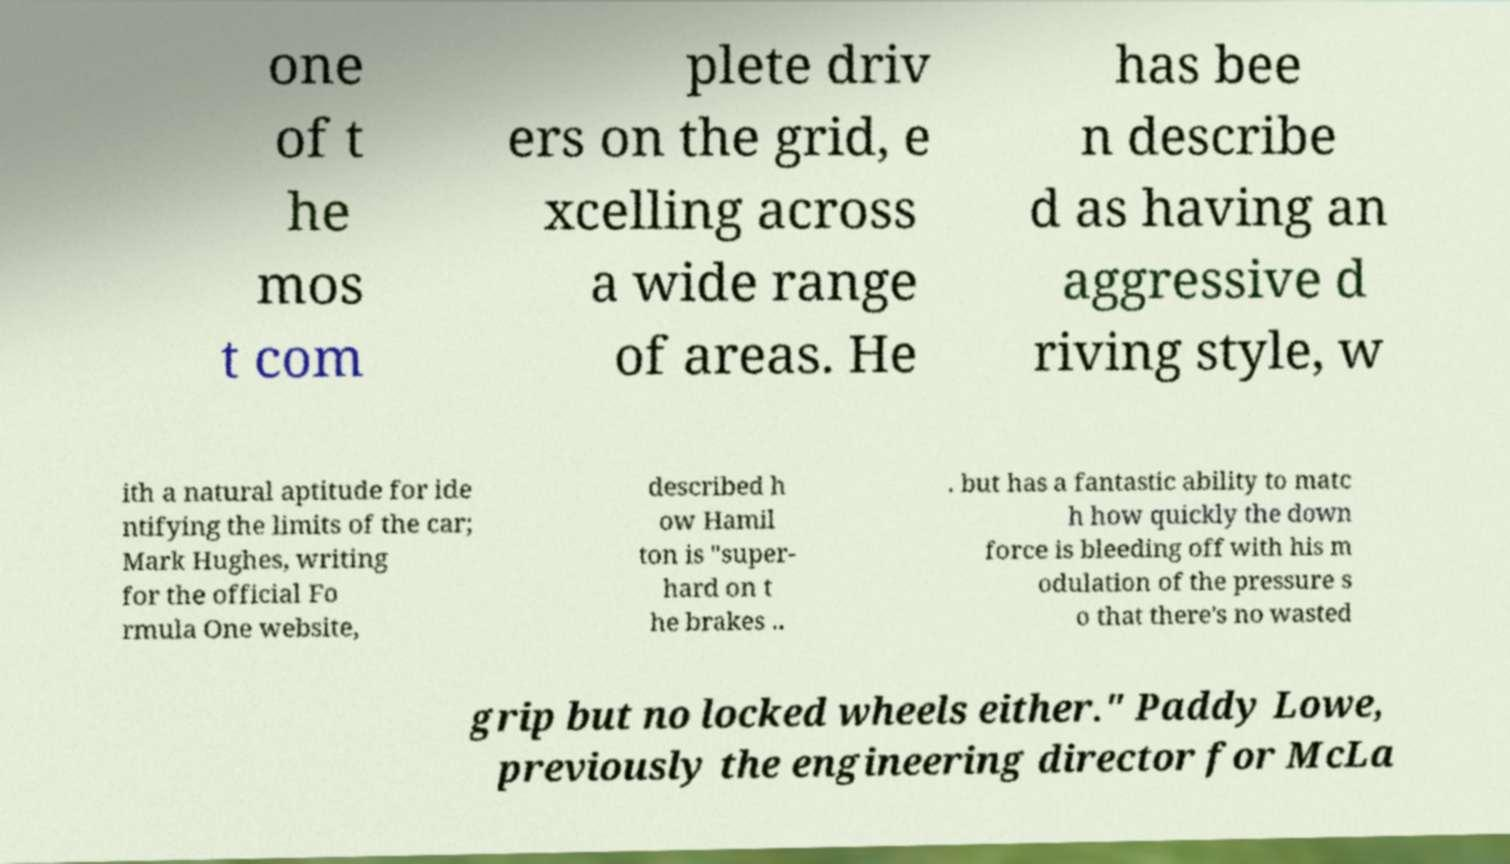There's text embedded in this image that I need extracted. Can you transcribe it verbatim? one of t he mos t com plete driv ers on the grid, e xcelling across a wide range of areas. He has bee n describe d as having an aggressive d riving style, w ith a natural aptitude for ide ntifying the limits of the car; Mark Hughes, writing for the official Fo rmula One website, described h ow Hamil ton is "super- hard on t he brakes .. . but has a fantastic ability to matc h how quickly the down force is bleeding off with his m odulation of the pressure s o that there's no wasted grip but no locked wheels either." Paddy Lowe, previously the engineering director for McLa 